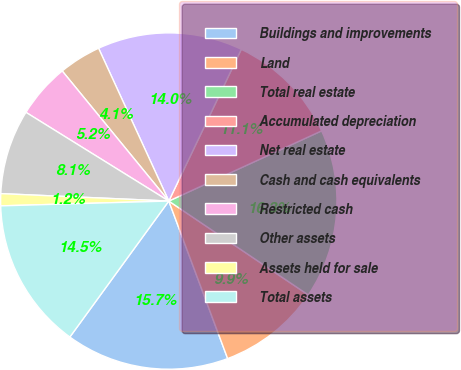<chart> <loc_0><loc_0><loc_500><loc_500><pie_chart><fcel>Buildings and improvements<fcel>Land<fcel>Total real estate<fcel>Accumulated depreciation<fcel>Net real estate<fcel>Cash and cash equivalents<fcel>Restricted cash<fcel>Other assets<fcel>Assets held for sale<fcel>Total assets<nl><fcel>15.7%<fcel>9.88%<fcel>16.28%<fcel>11.05%<fcel>13.95%<fcel>4.07%<fcel>5.23%<fcel>8.14%<fcel>1.16%<fcel>14.53%<nl></chart> 